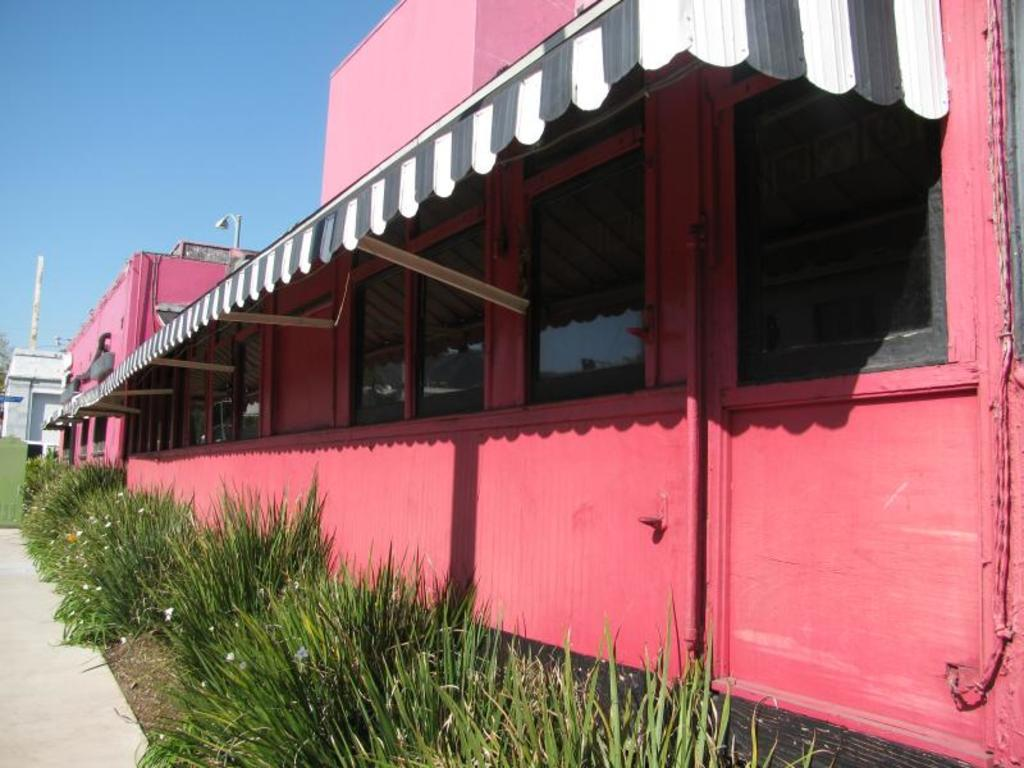What type of structures can be seen in the image? There are buildings in the image. Can you describe the relationship between the shed and the building? The shed is attached to a building in the image. What type of vegetation is present in the image? There are plants in front of the building in the image. What can be seen in the distance in the image? The sky is visible in the background of the image. What type of breakfast is being served in the image? There is no breakfast present in the image; it features buildings, a shed, plants, and the sky. Who is the achiever in the image? There is no individual or achievement depicted in the image; it focuses on buildings, a shed, plants, and the sky. 